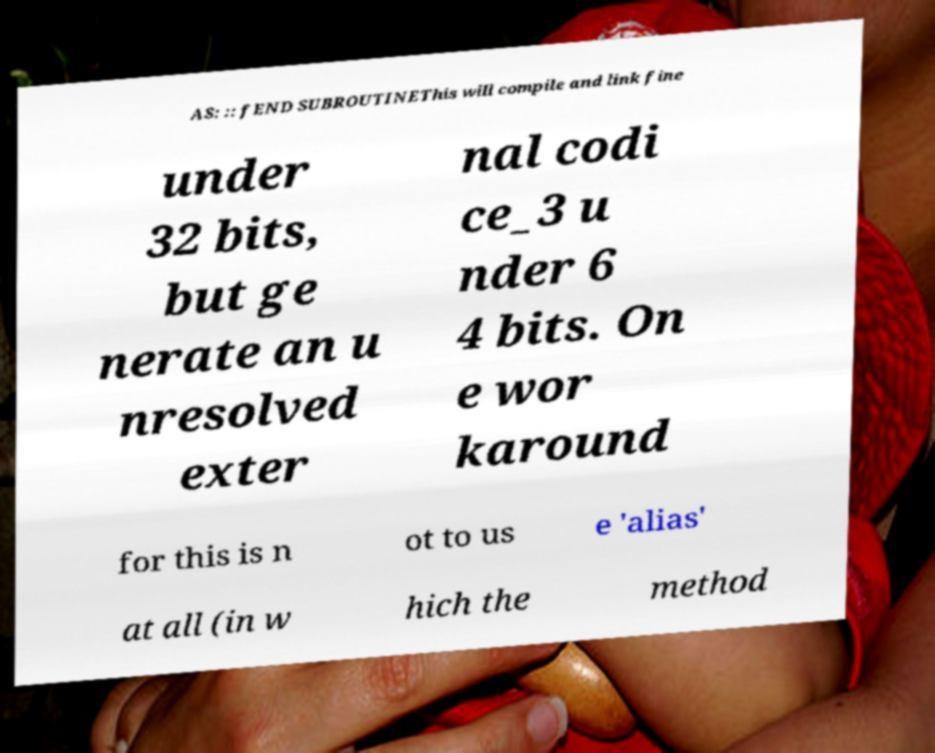Can you accurately transcribe the text from the provided image for me? AS: :: fEND SUBROUTINEThis will compile and link fine under 32 bits, but ge nerate an u nresolved exter nal codi ce_3 u nder 6 4 bits. On e wor karound for this is n ot to us e 'alias' at all (in w hich the method 